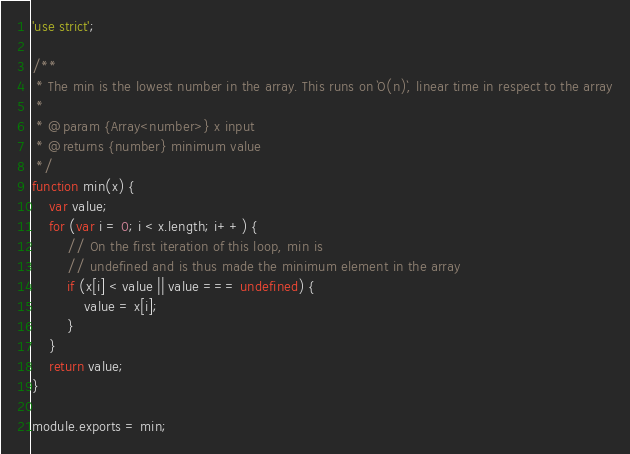<code> <loc_0><loc_0><loc_500><loc_500><_JavaScript_>'use strict';

/**
 * The min is the lowest number in the array. This runs on `O(n)`, linear time in respect to the array
 *
 * @param {Array<number>} x input
 * @returns {number} minimum value
 */
function min(x) {
    var value;
    for (var i = 0; i < x.length; i++) {
        // On the first iteration of this loop, min is
        // undefined and is thus made the minimum element in the array
        if (x[i] < value || value === undefined) {
            value = x[i];
        }
    }
    return value;
}

module.exports = min;
</code> 